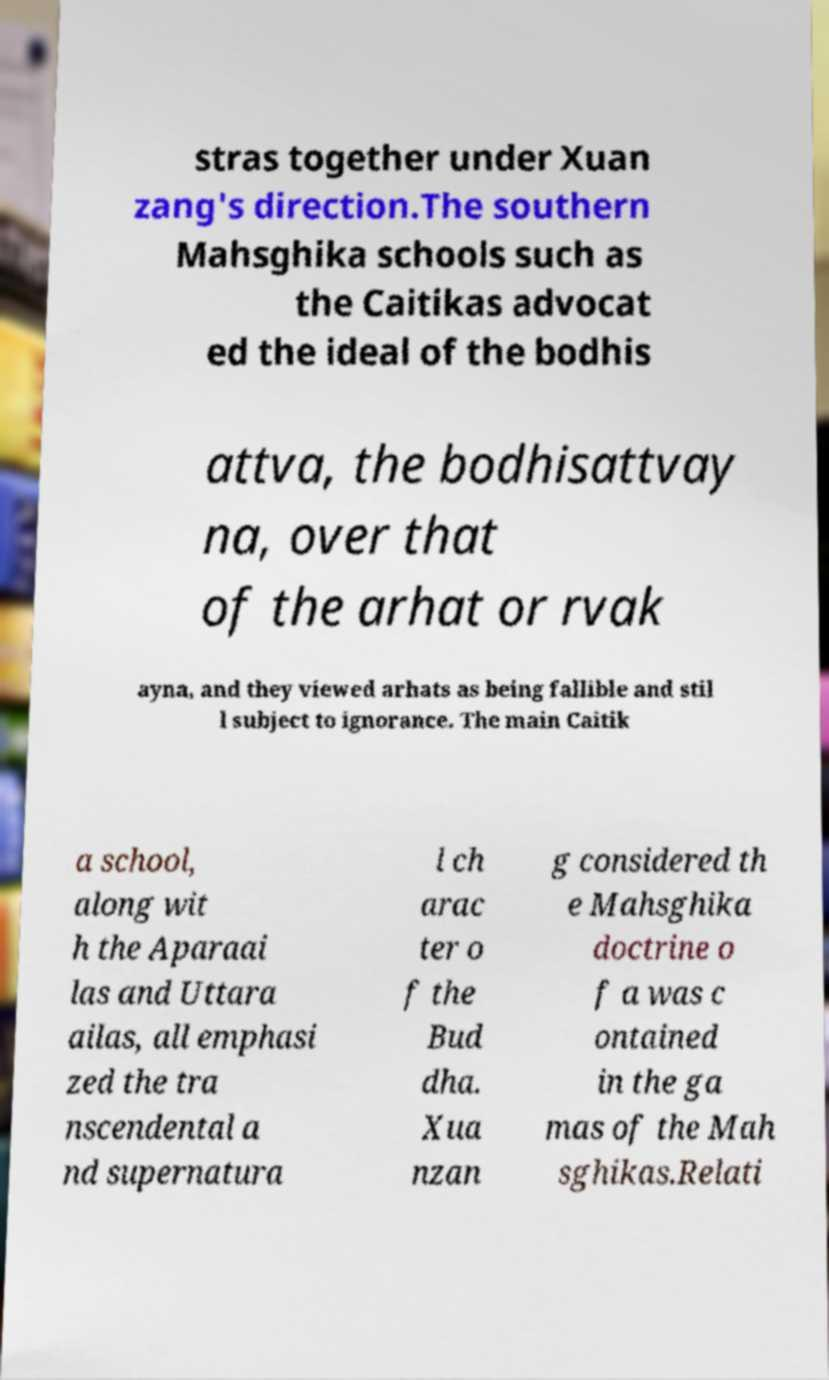Could you extract and type out the text from this image? stras together under Xuan zang's direction.The southern Mahsghika schools such as the Caitikas advocat ed the ideal of the bodhis attva, the bodhisattvay na, over that of the arhat or rvak ayna, and they viewed arhats as being fallible and stil l subject to ignorance. The main Caitik a school, along wit h the Aparaai las and Uttara ailas, all emphasi zed the tra nscendental a nd supernatura l ch arac ter o f the Bud dha. Xua nzan g considered th e Mahsghika doctrine o f a was c ontained in the ga mas of the Mah sghikas.Relati 